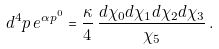Convert formula to latex. <formula><loc_0><loc_0><loc_500><loc_500>d ^ { 4 } p \, e ^ { \alpha p ^ { 0 } } = \frac { \kappa } 4 \, \frac { d \chi _ { 0 } d \chi _ { 1 } d \chi _ { 2 } d \chi _ { 3 } } { \chi _ { 5 } } \, .</formula> 